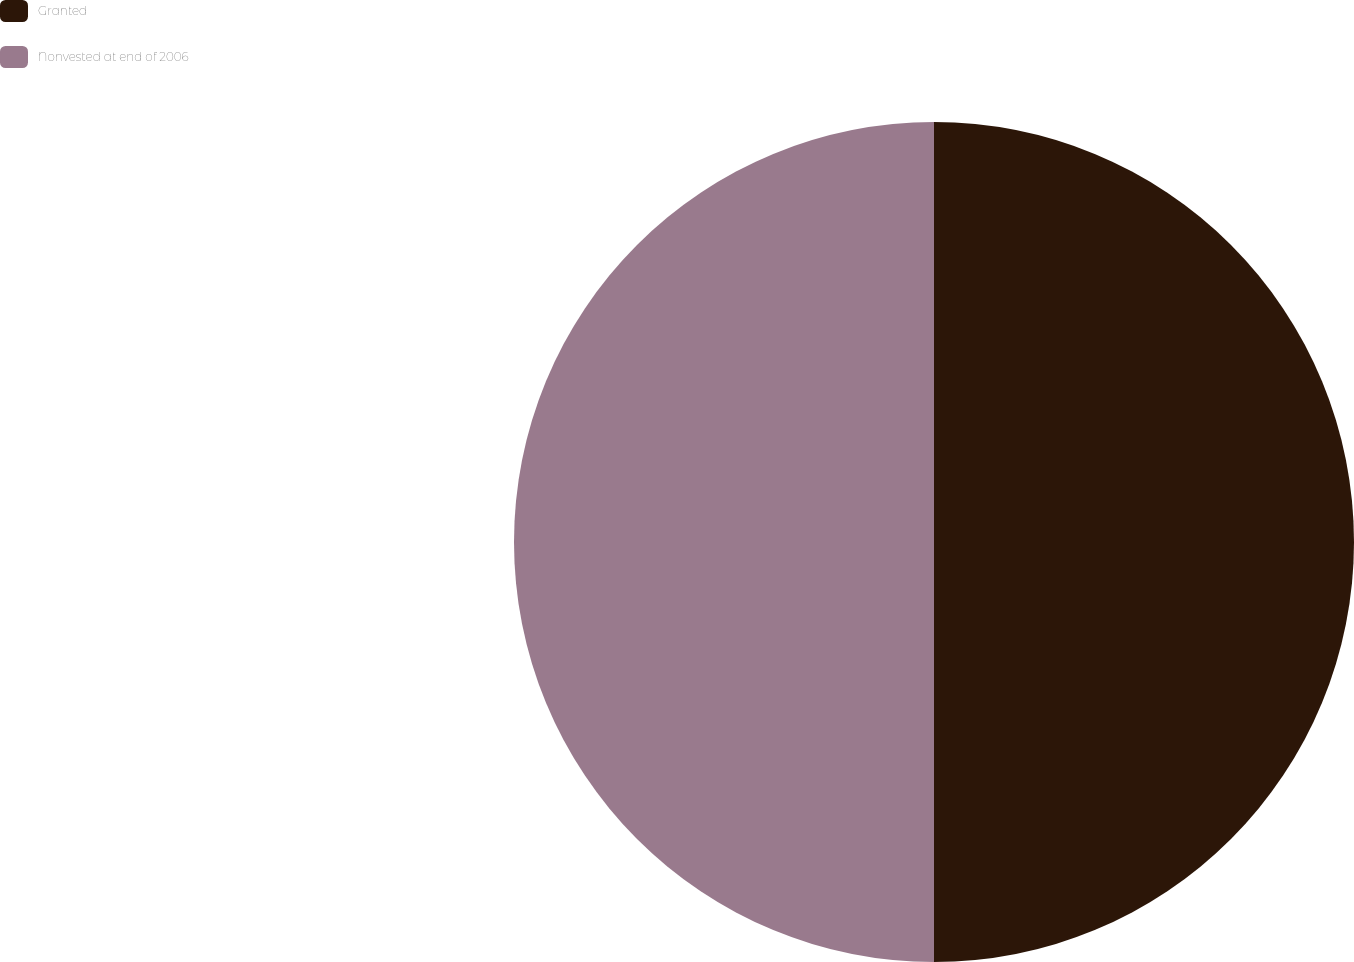Convert chart. <chart><loc_0><loc_0><loc_500><loc_500><pie_chart><fcel>Granted<fcel>Nonvested at end of 2006<nl><fcel>50.0%<fcel>50.0%<nl></chart> 